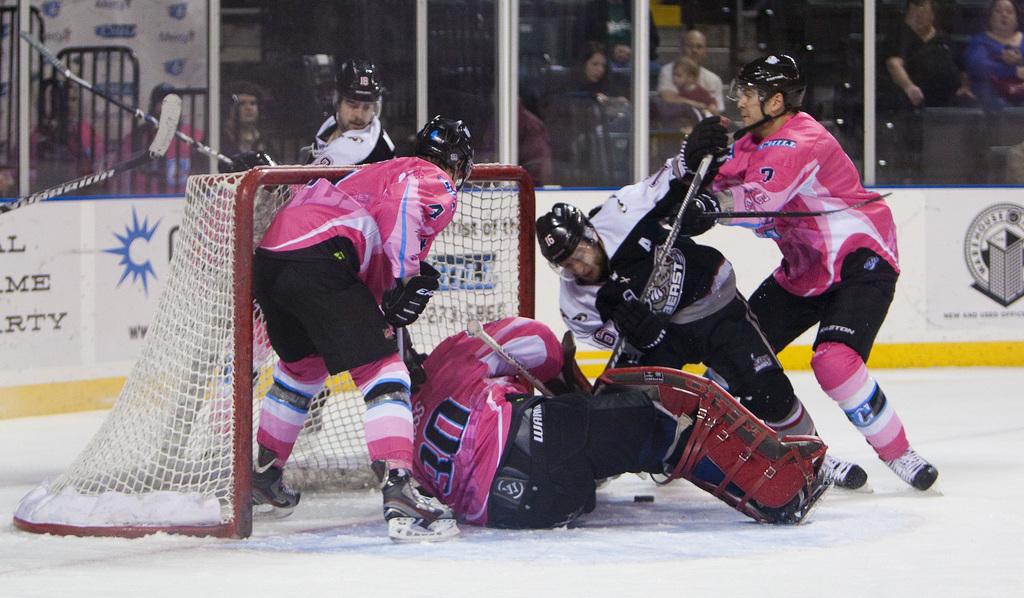What number on the back of jersey?
Offer a very short reply. 30. 